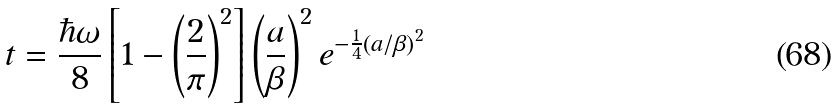Convert formula to latex. <formula><loc_0><loc_0><loc_500><loc_500>t = \frac { \hbar { \omega } } { 8 } \left [ 1 - \left ( \frac { 2 } { \pi } \right ) ^ { 2 } \right ] \left ( \frac { a } { \beta } \right ) ^ { 2 } e ^ { - \frac { 1 } { 4 } \left ( a / \beta \right ) ^ { 2 } }</formula> 